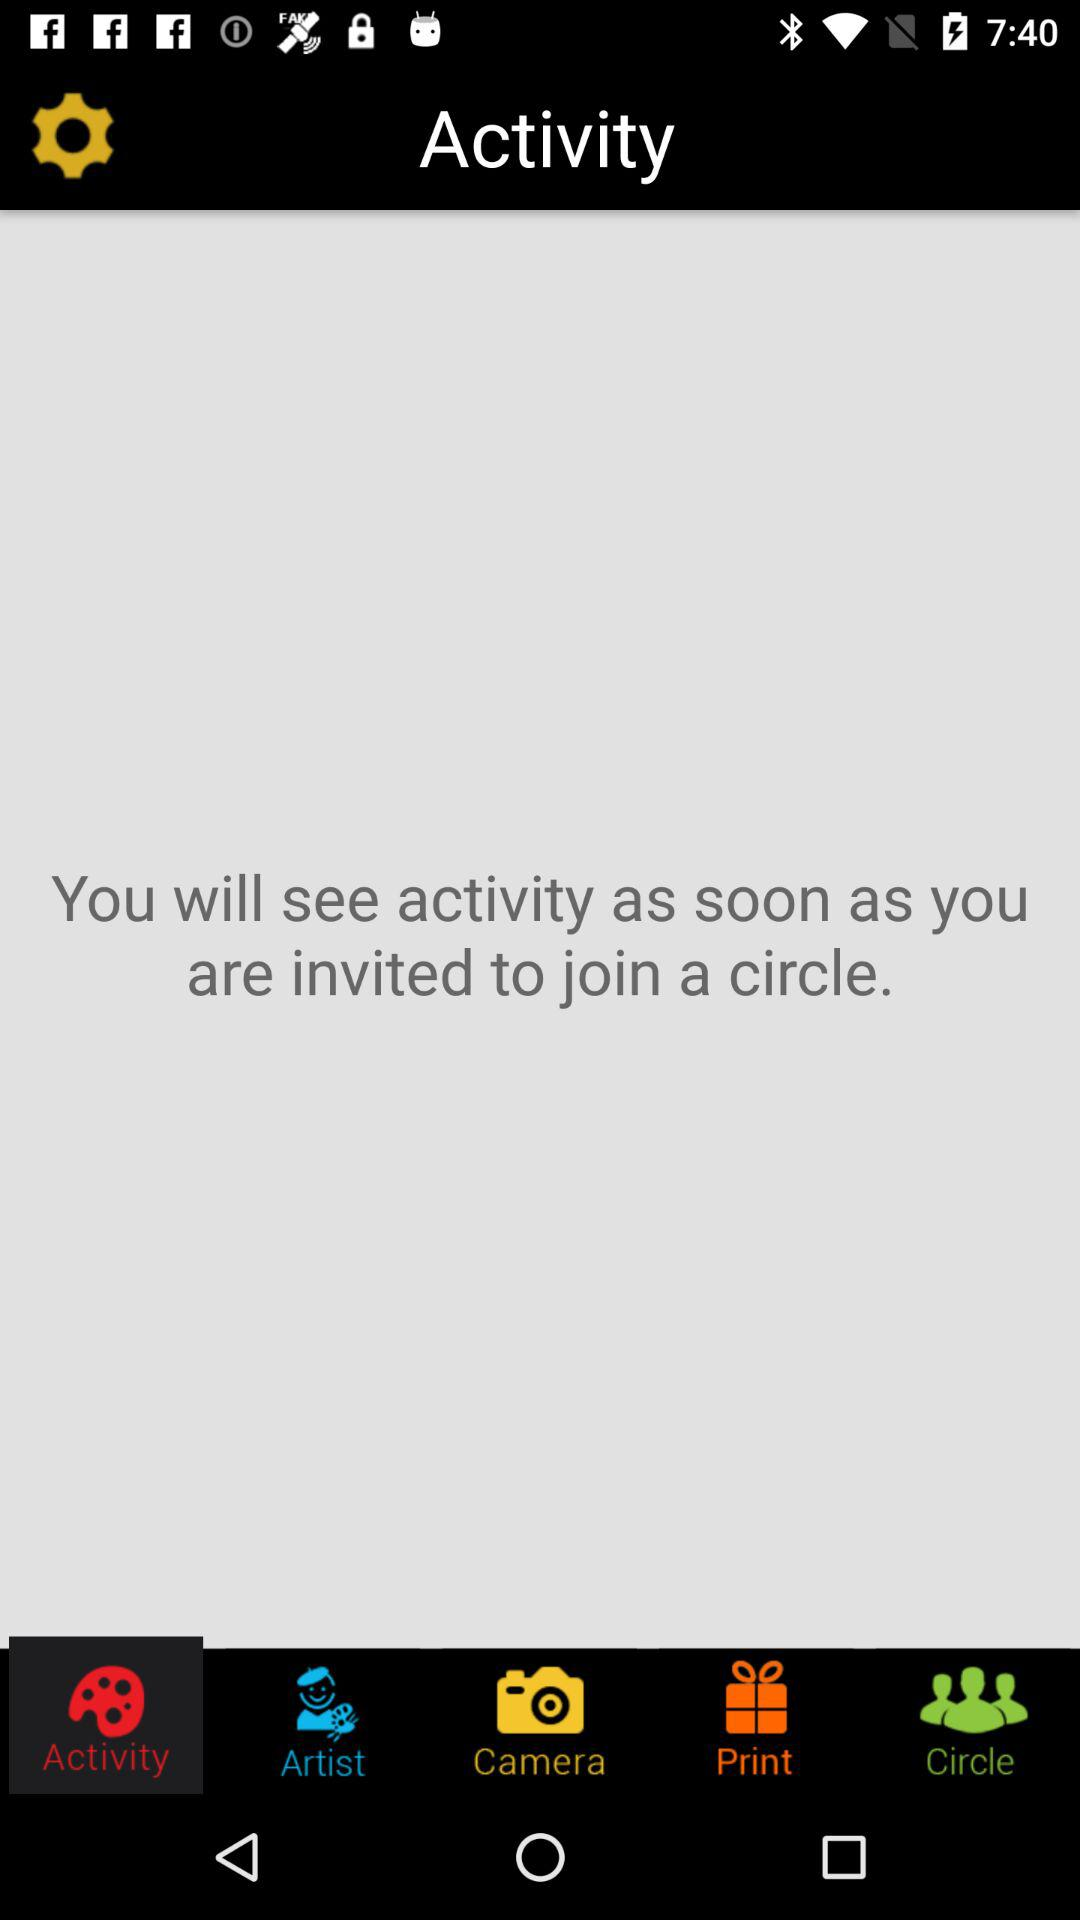How many notifications are there in "Circle"?
When the provided information is insufficient, respond with <no answer>. <no answer> 